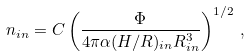Convert formula to latex. <formula><loc_0><loc_0><loc_500><loc_500>n _ { i n } = C \left ( \frac { \Phi } { 4 \pi \alpha ( H / R ) _ { i n } R _ { i n } ^ { 3 } } \right ) ^ { 1 / 2 } \, ,</formula> 